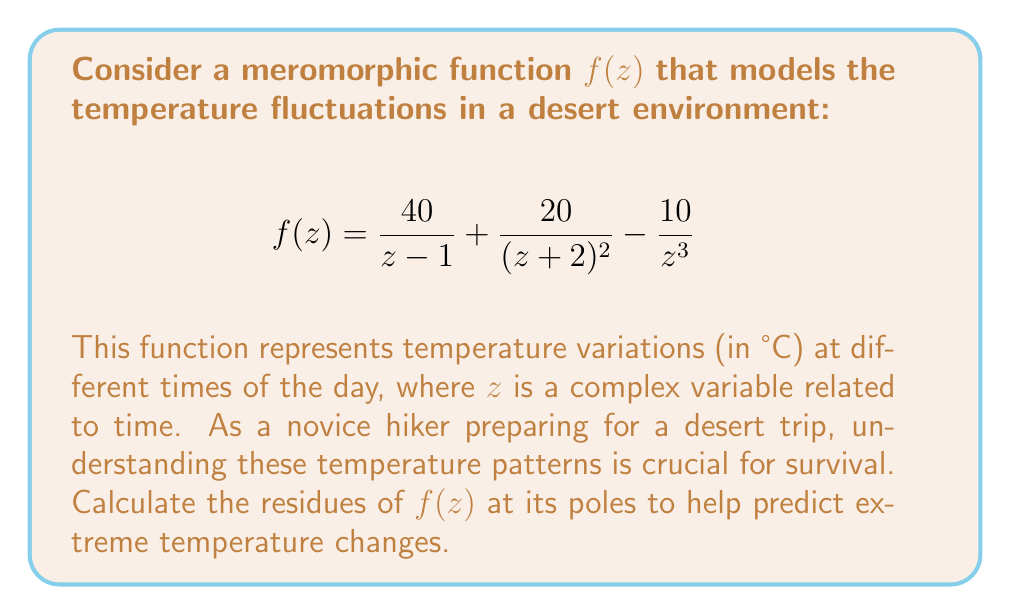Solve this math problem. Let's calculate the residues step by step:

1) First, identify the poles of $f(z)$:
   - $z = 1$ (simple pole)
   - $z = -2$ (double pole)
   - $z = 0$ (triple pole)

2) For the simple pole at $z = 1$:
   The residue is the coefficient of the $(z-1)^{-1}$ term.
   $\text{Res}(f, 1) = 40$

3) For the double pole at $z = -2$:
   Use the formula for the residue at a pole of order 2:
   $\text{Res}(f, -2) = \lim_{z \to -2} \frac{d}{dz}[(z+2)^2 \cdot \frac{20}{(z+2)^2}] = \lim_{z \to -2} \frac{d}{dz}[20] = 0$

4) For the triple pole at $z = 0$:
   Use the formula for the residue at a pole of order 3:
   $\text{Res}(f, 0) = \frac{1}{2!} \lim_{z \to 0} \frac{d^2}{dz^2}[z^3 \cdot (-\frac{10}{z^3})]$
   $= \frac{1}{2} \lim_{z \to 0} \frac{d^2}{dz^2}[-10] = 0$

These residues help predict the severity and frequency of temperature fluctuations, which is crucial information for a desert hiker's survival planning.
Answer: $\text{Res}(f, 1) = 40$, $\text{Res}(f, -2) = 0$, $\text{Res}(f, 0) = 0$ 